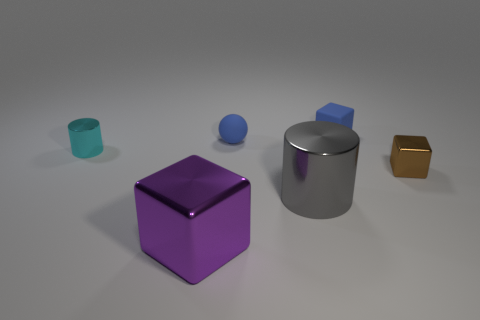Add 1 shiny things. How many objects exist? 7 Subtract all balls. How many objects are left? 5 Subtract 0 yellow cylinders. How many objects are left? 6 Subtract all blue cubes. Subtract all tiny brown cubes. How many objects are left? 4 Add 3 small brown shiny blocks. How many small brown shiny blocks are left? 4 Add 4 tiny blue objects. How many tiny blue objects exist? 6 